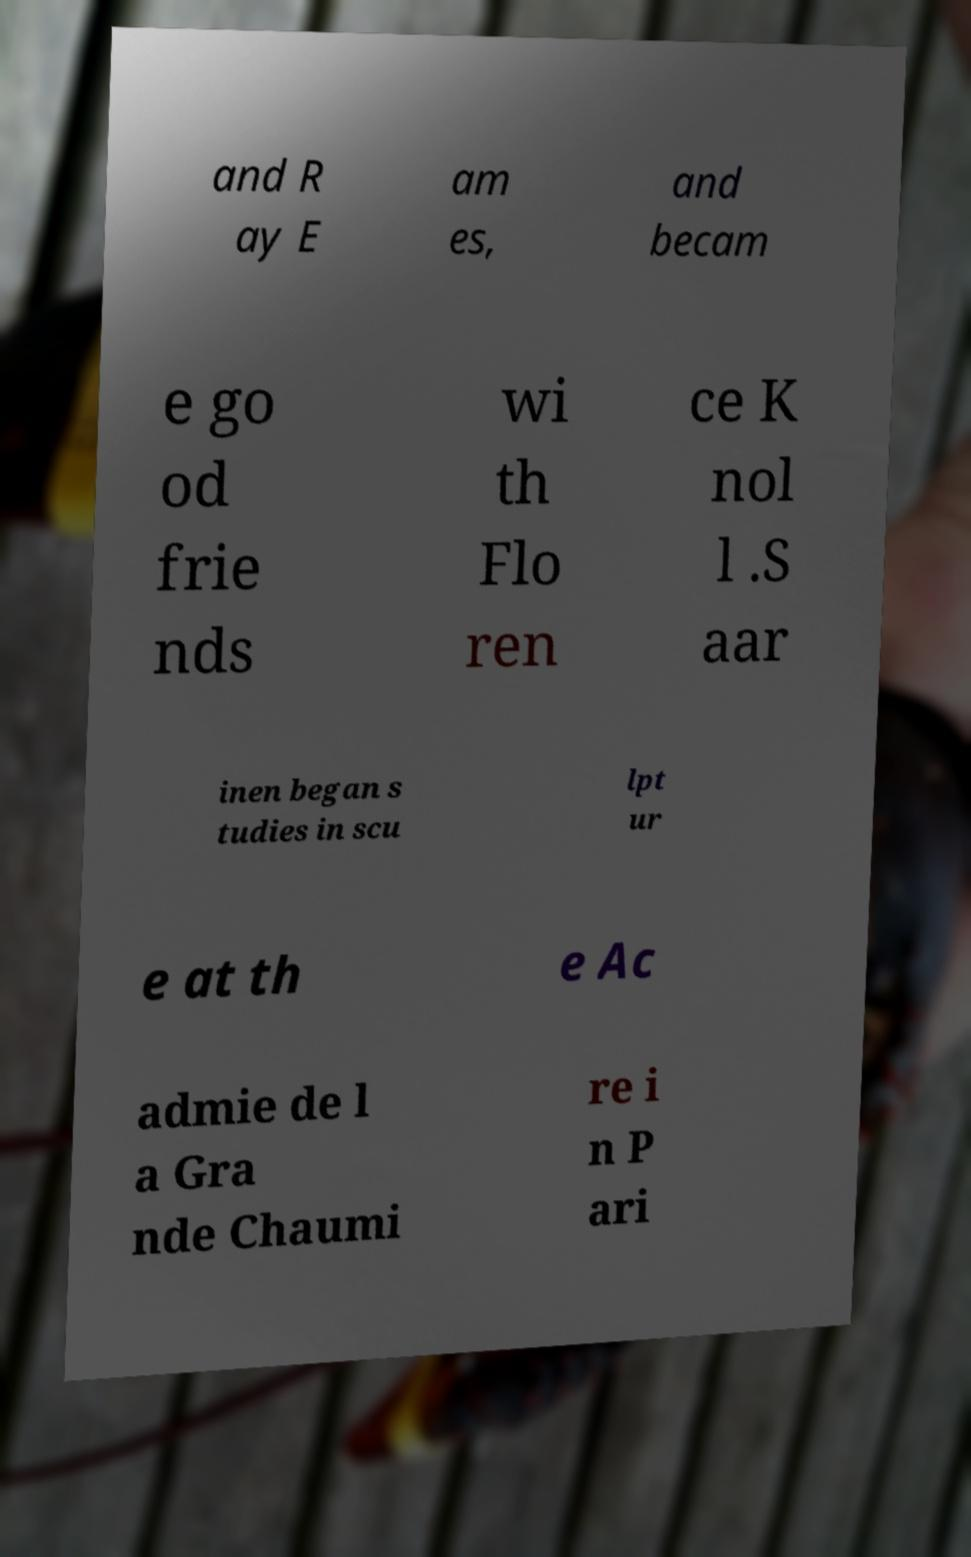Please read and relay the text visible in this image. What does it say? and R ay E am es, and becam e go od frie nds wi th Flo ren ce K nol l .S aar inen began s tudies in scu lpt ur e at th e Ac admie de l a Gra nde Chaumi re i n P ari 